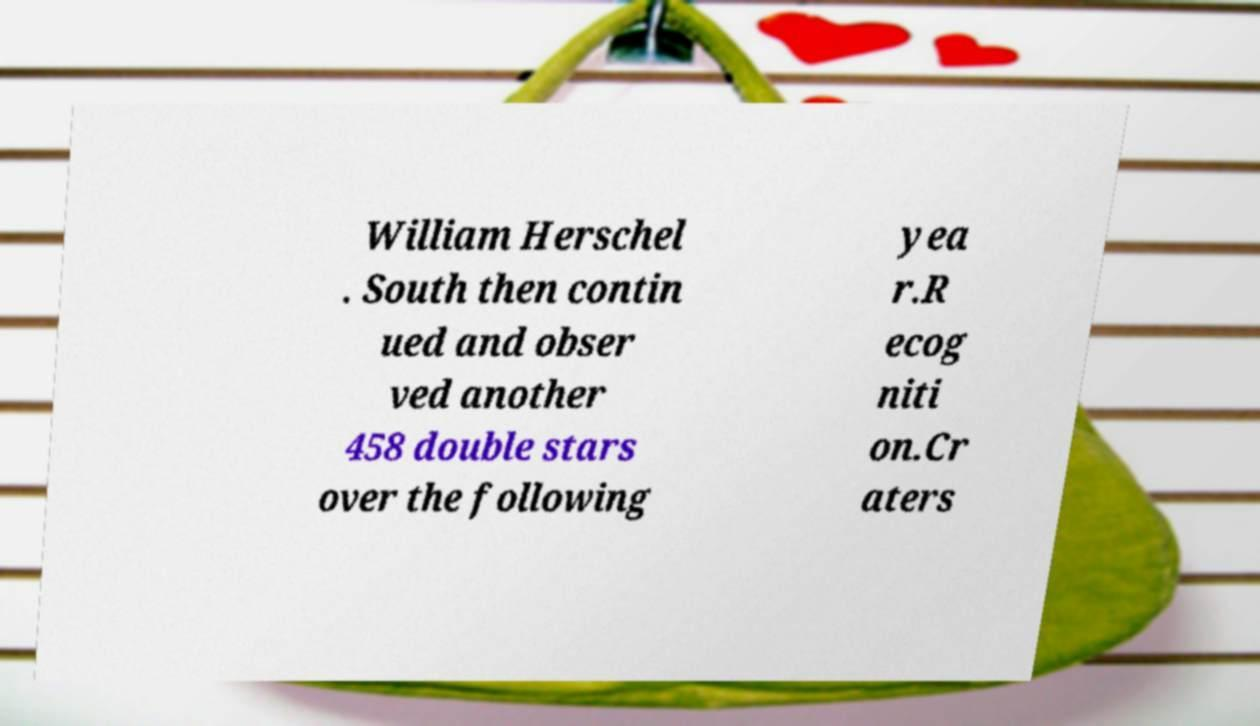There's text embedded in this image that I need extracted. Can you transcribe it verbatim? William Herschel . South then contin ued and obser ved another 458 double stars over the following yea r.R ecog niti on.Cr aters 